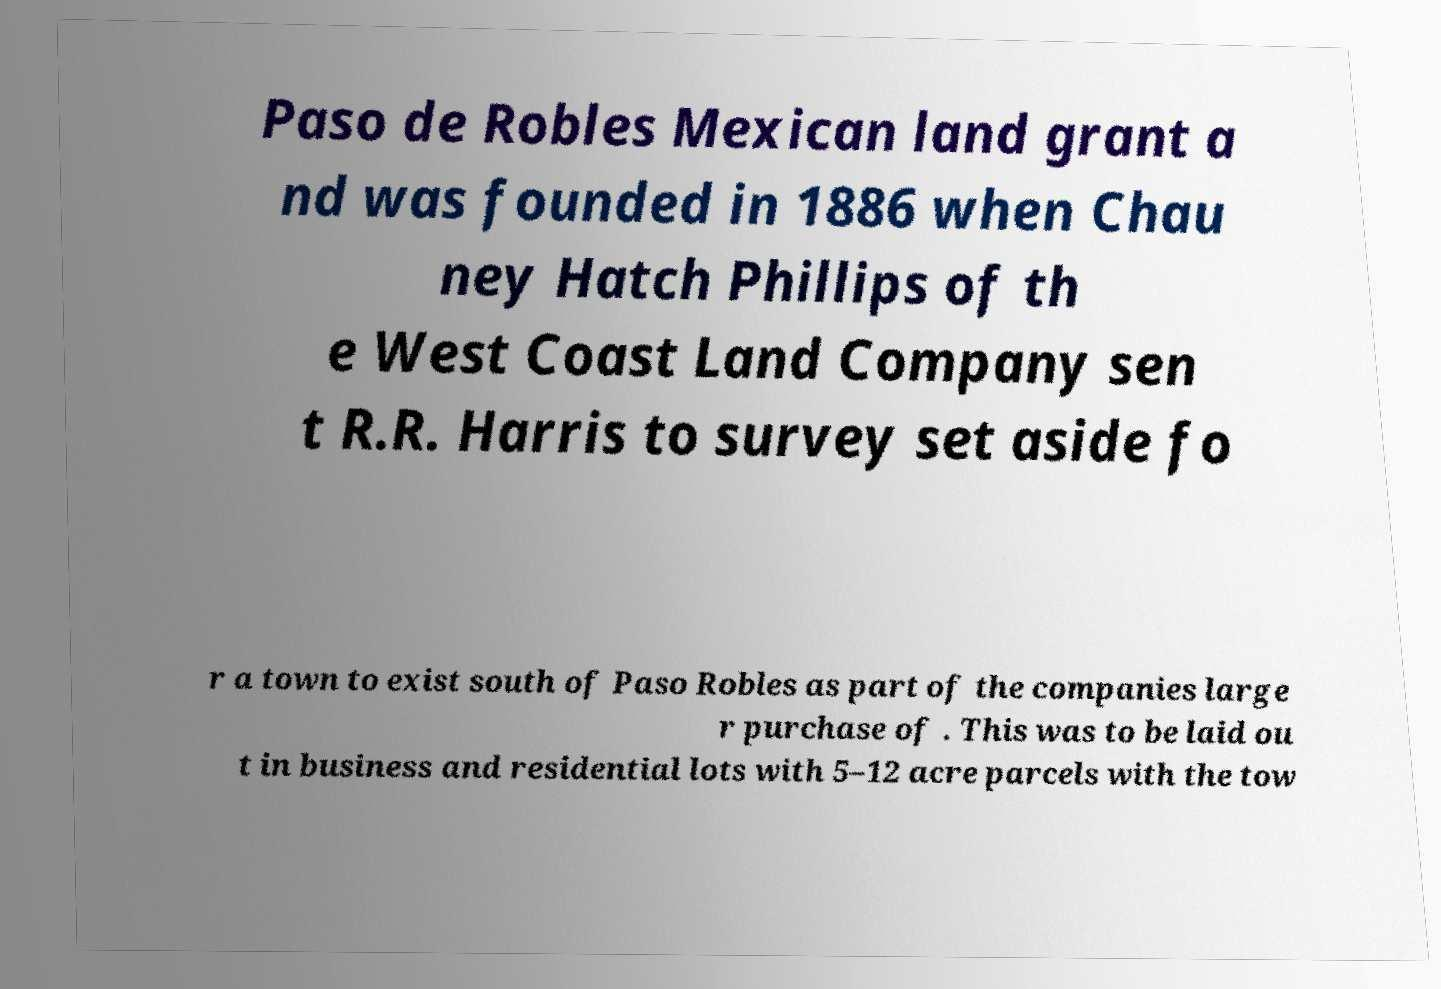Please read and relay the text visible in this image. What does it say? Paso de Robles Mexican land grant a nd was founded in 1886 when Chau ney Hatch Phillips of th e West Coast Land Company sen t R.R. Harris to survey set aside fo r a town to exist south of Paso Robles as part of the companies large r purchase of . This was to be laid ou t in business and residential lots with 5–12 acre parcels with the tow 